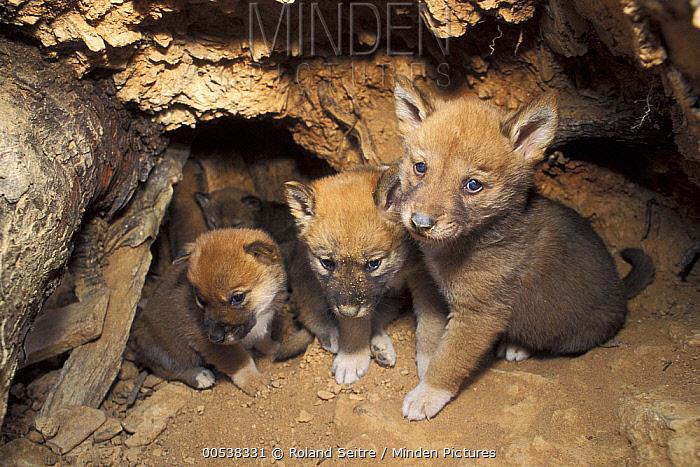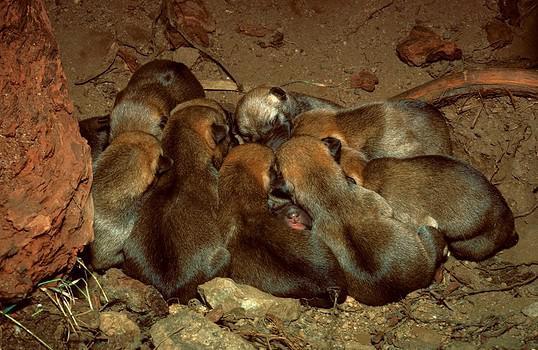The first image is the image on the left, the second image is the image on the right. Given the left and right images, does the statement "One image shows only multiple pups, and the other image shows a mother dog with pups." hold true? Answer yes or no. No. The first image is the image on the left, the second image is the image on the right. For the images displayed, is the sentence "In the image on the right several puppies are nestled on straw." factually correct? Answer yes or no. No. 